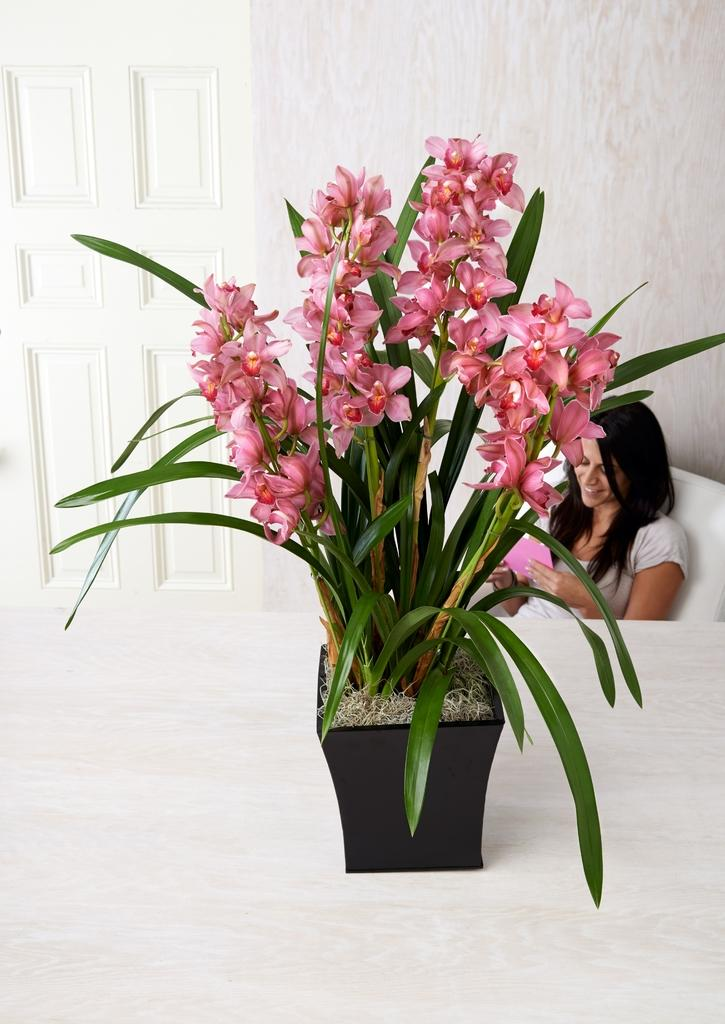What type of plant can be seen in the image? There is a plant with flowers in a pot in the image. Where is the pot with the plant located? The pot is placed on a surface in the image. What is the woman in the image doing? The woman is holding papers in the image. What is the woman sitting on? The woman is sitting on a sofa in the image. What architectural feature can be seen in the image? There is a door visible in the image. What is the background of the image made of? There is a wall in the image. What type of mask is the mom wearing in the image? There is no mom or mask present in the image. What is the rate of the woman's heartbeat in the image? There is no information about the woman's heartbeat in the image. 